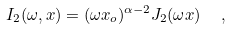<formula> <loc_0><loc_0><loc_500><loc_500>I _ { 2 } ( \omega , x ) = ( \omega x _ { o } ) ^ { \alpha - 2 } J _ { 2 } ( \omega x ) \ \ ,</formula> 